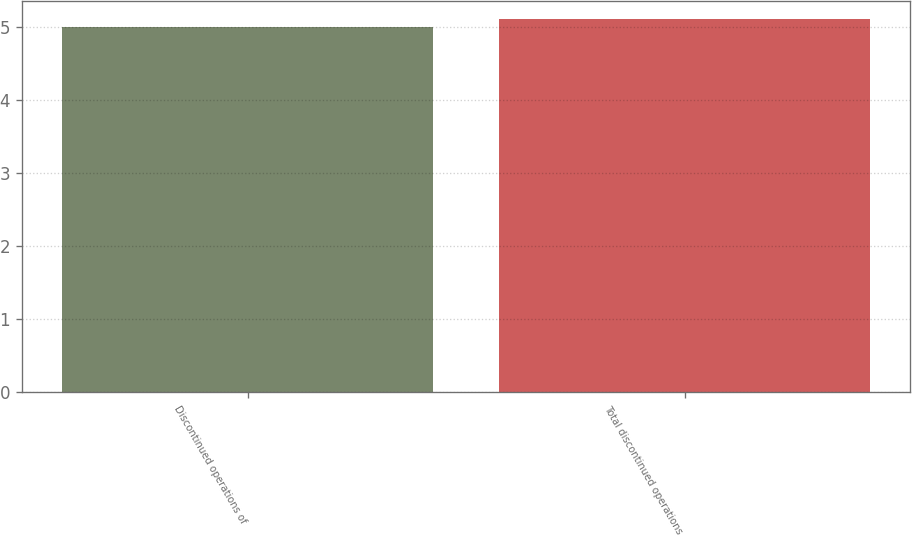Convert chart. <chart><loc_0><loc_0><loc_500><loc_500><bar_chart><fcel>Discontinued operations of<fcel>Total discontinued operations<nl><fcel>5<fcel>5.1<nl></chart> 